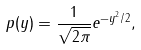Convert formula to latex. <formula><loc_0><loc_0><loc_500><loc_500>p ( y ) = \frac { 1 } { \sqrt { 2 \pi } } e ^ { - y ^ { 2 } / 2 } ,</formula> 